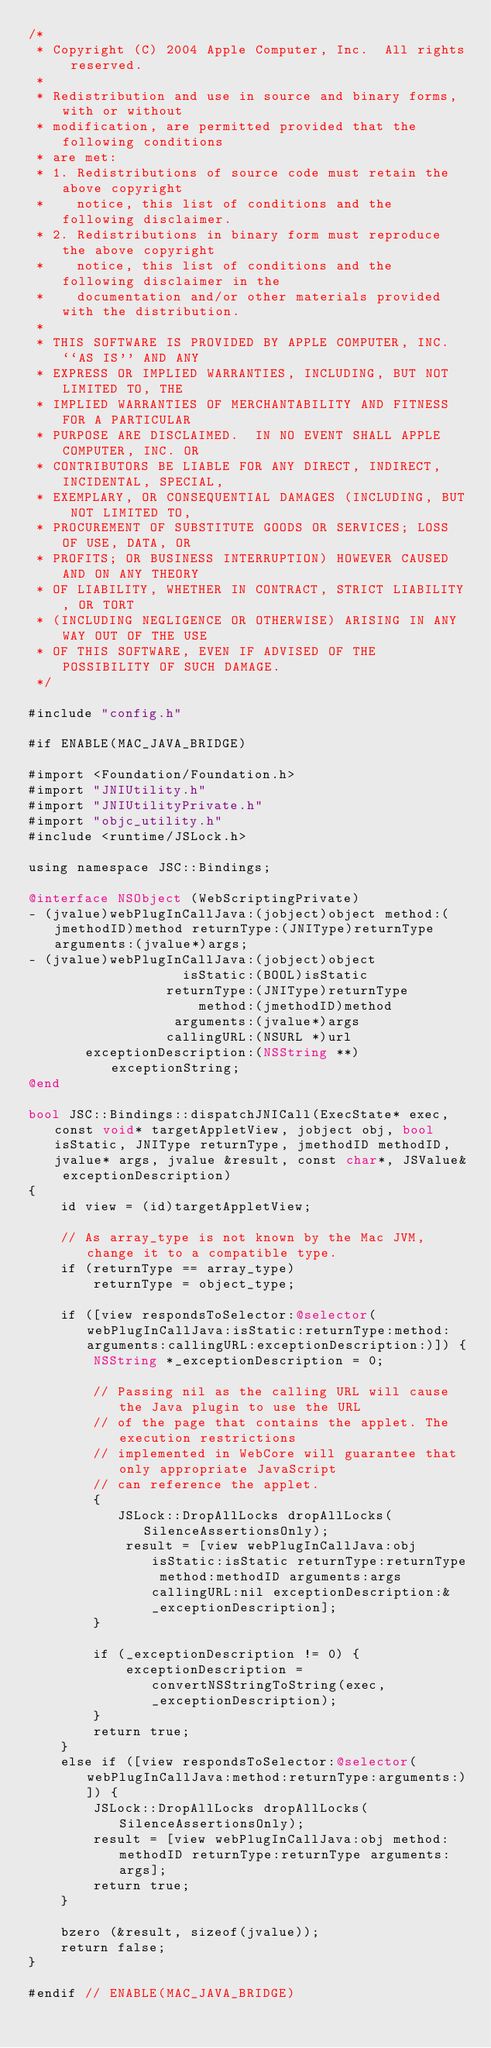Convert code to text. <code><loc_0><loc_0><loc_500><loc_500><_ObjectiveC_>/*
 * Copyright (C) 2004 Apple Computer, Inc.  All rights reserved.
 *
 * Redistribution and use in source and binary forms, with or without
 * modification, are permitted provided that the following conditions
 * are met:
 * 1. Redistributions of source code must retain the above copyright
 *    notice, this list of conditions and the following disclaimer.
 * 2. Redistributions in binary form must reproduce the above copyright
 *    notice, this list of conditions and the following disclaimer in the
 *    documentation and/or other materials provided with the distribution.
 *
 * THIS SOFTWARE IS PROVIDED BY APPLE COMPUTER, INC. ``AS IS'' AND ANY
 * EXPRESS OR IMPLIED WARRANTIES, INCLUDING, BUT NOT LIMITED TO, THE
 * IMPLIED WARRANTIES OF MERCHANTABILITY AND FITNESS FOR A PARTICULAR
 * PURPOSE ARE DISCLAIMED.  IN NO EVENT SHALL APPLE COMPUTER, INC. OR
 * CONTRIBUTORS BE LIABLE FOR ANY DIRECT, INDIRECT, INCIDENTAL, SPECIAL,
 * EXEMPLARY, OR CONSEQUENTIAL DAMAGES (INCLUDING, BUT NOT LIMITED TO,
 * PROCUREMENT OF SUBSTITUTE GOODS OR SERVICES; LOSS OF USE, DATA, OR
 * PROFITS; OR BUSINESS INTERRUPTION) HOWEVER CAUSED AND ON ANY THEORY
 * OF LIABILITY, WHETHER IN CONTRACT, STRICT LIABILITY, OR TORT
 * (INCLUDING NEGLIGENCE OR OTHERWISE) ARISING IN ANY WAY OUT OF THE USE
 * OF THIS SOFTWARE, EVEN IF ADVISED OF THE POSSIBILITY OF SUCH DAMAGE. 
 */

#include "config.h"

#if ENABLE(MAC_JAVA_BRIDGE)

#import <Foundation/Foundation.h>
#import "JNIUtility.h"
#import "JNIUtilityPrivate.h"
#import "objc_utility.h"
#include <runtime/JSLock.h>

using namespace JSC::Bindings;

@interface NSObject (WebScriptingPrivate)
- (jvalue)webPlugInCallJava:(jobject)object method:(jmethodID)method returnType:(JNIType)returnType arguments:(jvalue*)args;
- (jvalue)webPlugInCallJava:(jobject)object
                   isStatic:(BOOL)isStatic
                 returnType:(JNIType)returnType
                     method:(jmethodID)method
                  arguments:(jvalue*)args
                 callingURL:(NSURL *)url
       exceptionDescription:(NSString **)exceptionString;
@end

bool JSC::Bindings::dispatchJNICall(ExecState* exec, const void* targetAppletView, jobject obj, bool isStatic, JNIType returnType, jmethodID methodID, jvalue* args, jvalue &result, const char*, JSValue& exceptionDescription)
{
    id view = (id)targetAppletView;
    
    // As array_type is not known by the Mac JVM, change it to a compatible type.
    if (returnType == array_type)
        returnType = object_type;
    
    if ([view respondsToSelector:@selector(webPlugInCallJava:isStatic:returnType:method:arguments:callingURL:exceptionDescription:)]) {
        NSString *_exceptionDescription = 0;

        // Passing nil as the calling URL will cause the Java plugin to use the URL
        // of the page that contains the applet. The execution restrictions 
        // implemented in WebCore will guarantee that only appropriate JavaScript
        // can reference the applet.
        {
           JSLock::DropAllLocks dropAllLocks(SilenceAssertionsOnly);
            result = [view webPlugInCallJava:obj isStatic:isStatic returnType:returnType method:methodID arguments:args callingURL:nil exceptionDescription:&_exceptionDescription];
        }

        if (_exceptionDescription != 0) {
            exceptionDescription = convertNSStringToString(exec, _exceptionDescription);
        }
        return true;
    }
    else if ([view respondsToSelector:@selector(webPlugInCallJava:method:returnType:arguments:)]) {
        JSLock::DropAllLocks dropAllLocks(SilenceAssertionsOnly);
        result = [view webPlugInCallJava:obj method:methodID returnType:returnType arguments:args];
        return true;
    }

    bzero (&result, sizeof(jvalue));
    return false;
}

#endif // ENABLE(MAC_JAVA_BRIDGE)
</code> 